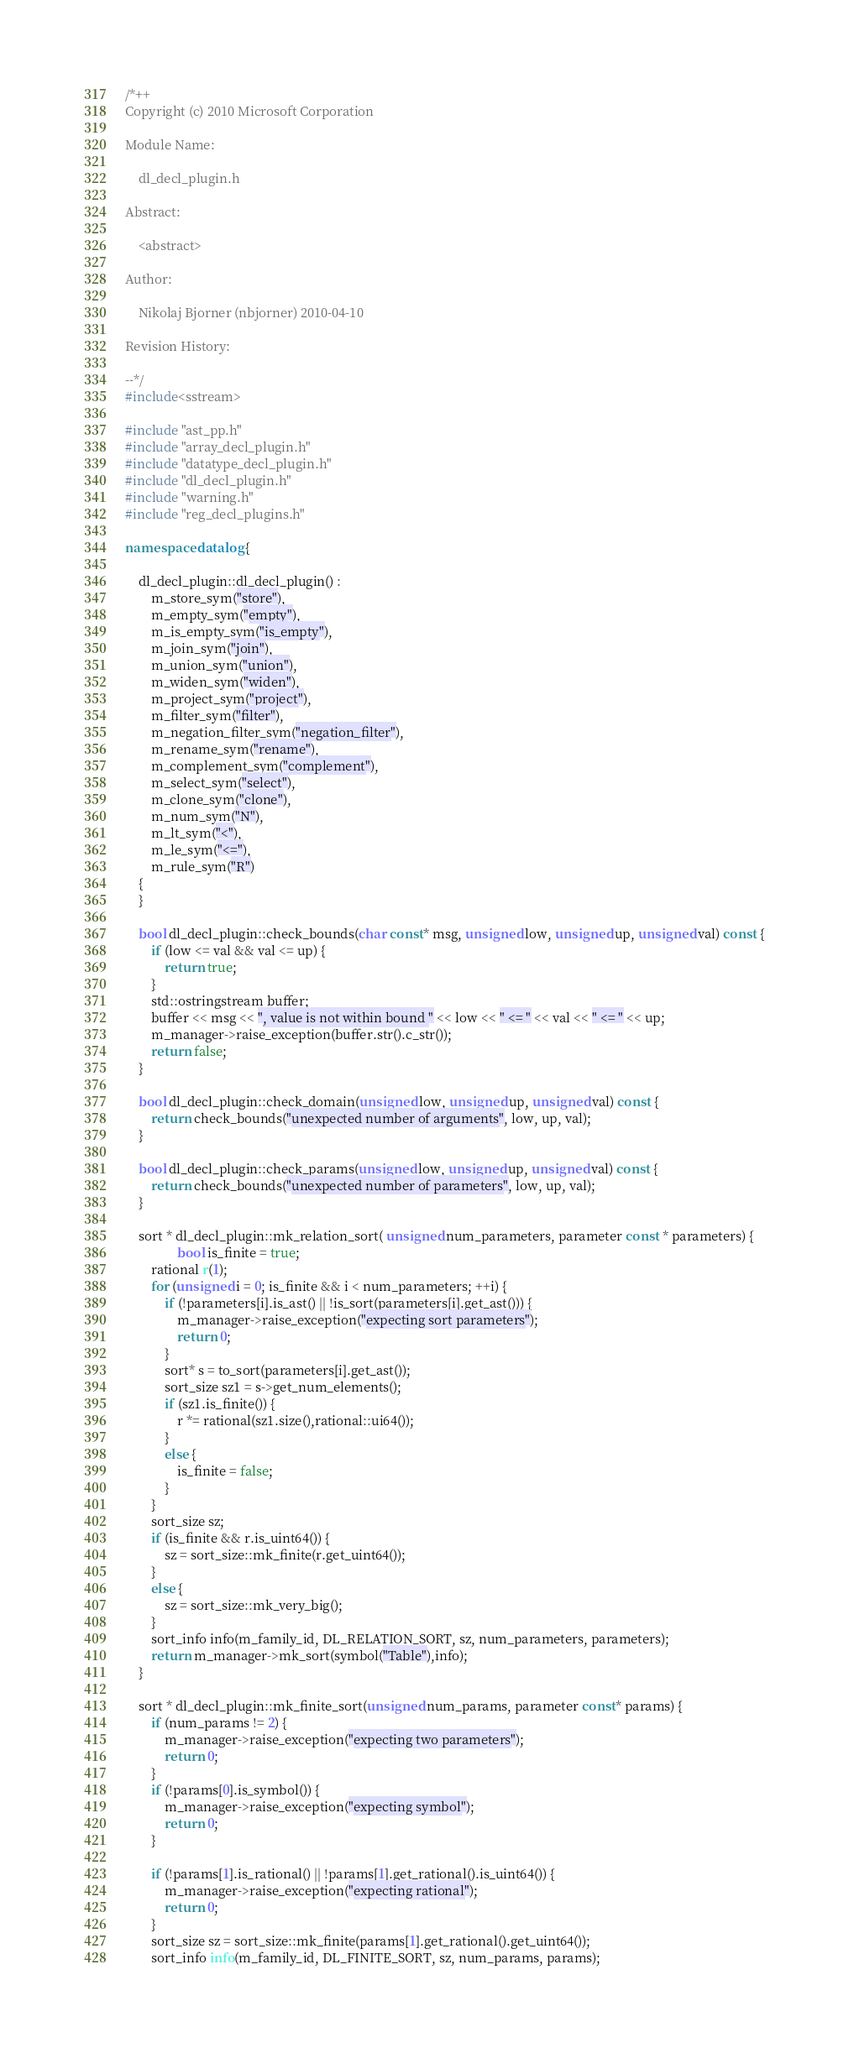<code> <loc_0><loc_0><loc_500><loc_500><_C++_>/*++
Copyright (c) 2010 Microsoft Corporation

Module Name:

    dl_decl_plugin.h

Abstract:

    <abstract>

Author:

    Nikolaj Bjorner (nbjorner) 2010-04-10

Revision History:

--*/
#include<sstream>

#include "ast_pp.h"
#include "array_decl_plugin.h"
#include "datatype_decl_plugin.h"
#include "dl_decl_plugin.h"
#include "warning.h"
#include "reg_decl_plugins.h"

namespace datalog {

    dl_decl_plugin::dl_decl_plugin() :
        m_store_sym("store"),
        m_empty_sym("empty"),
        m_is_empty_sym("is_empty"),
        m_join_sym("join"),
        m_union_sym("union"),
        m_widen_sym("widen"),
        m_project_sym("project"),
        m_filter_sym("filter"),
        m_negation_filter_sym("negation_filter"),
        m_rename_sym("rename"),
        m_complement_sym("complement"),
        m_select_sym("select"),
        m_clone_sym("clone"),
        m_num_sym("N"),
        m_lt_sym("<"),
        m_le_sym("<="),
        m_rule_sym("R")
    {
    }

    bool dl_decl_plugin::check_bounds(char const* msg, unsigned low, unsigned up, unsigned val) const {
        if (low <= val && val <= up) {
            return true;
        }
        std::ostringstream buffer;
        buffer << msg << ", value is not within bound " << low << " <= " << val << " <= " << up;
        m_manager->raise_exception(buffer.str().c_str());
        return false;
    }

    bool dl_decl_plugin::check_domain(unsigned low, unsigned up, unsigned val) const {
        return check_bounds("unexpected number of arguments", low, up, val);
    }

    bool dl_decl_plugin::check_params(unsigned low, unsigned up, unsigned val) const {
        return check_bounds("unexpected number of parameters", low, up, val);
    }

    sort * dl_decl_plugin::mk_relation_sort( unsigned num_parameters, parameter const * parameters) {
                bool is_finite = true;
        rational r(1);
        for (unsigned i = 0; is_finite && i < num_parameters; ++i) {
            if (!parameters[i].is_ast() || !is_sort(parameters[i].get_ast())) {
                m_manager->raise_exception("expecting sort parameters");
                return 0;
            }
            sort* s = to_sort(parameters[i].get_ast());
            sort_size sz1 = s->get_num_elements();
            if (sz1.is_finite()) {
                r *= rational(sz1.size(),rational::ui64());
            }
            else {
                is_finite = false;
            }
        }
        sort_size sz;
        if (is_finite && r.is_uint64()) {
            sz = sort_size::mk_finite(r.get_uint64());
        }
        else {
            sz = sort_size::mk_very_big();
        }
        sort_info info(m_family_id, DL_RELATION_SORT, sz, num_parameters, parameters);
        return m_manager->mk_sort(symbol("Table"),info);
    }

    sort * dl_decl_plugin::mk_finite_sort(unsigned num_params, parameter const* params) {
        if (num_params != 2) {
            m_manager->raise_exception("expecting two parameters");
            return 0;
        }
        if (!params[0].is_symbol()) {
            m_manager->raise_exception("expecting symbol");
            return 0;
        }

        if (!params[1].is_rational() || !params[1].get_rational().is_uint64()) {
            m_manager->raise_exception("expecting rational");
            return 0;
        }
        sort_size sz = sort_size::mk_finite(params[1].get_rational().get_uint64());
        sort_info info(m_family_id, DL_FINITE_SORT, sz, num_params, params);</code> 